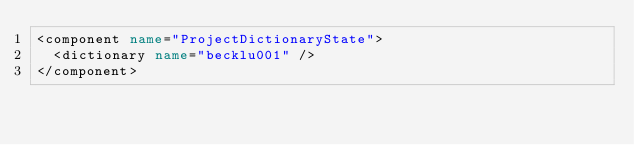Convert code to text. <code><loc_0><loc_0><loc_500><loc_500><_XML_><component name="ProjectDictionaryState">
  <dictionary name="becklu001" />
</component></code> 